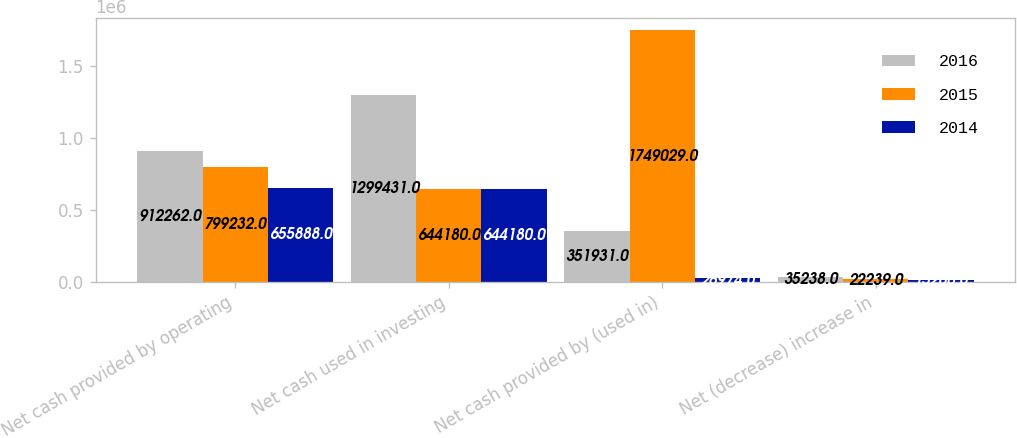Convert chart. <chart><loc_0><loc_0><loc_500><loc_500><stacked_bar_chart><ecel><fcel>Net cash provided by operating<fcel>Net cash used in investing<fcel>Net cash provided by (used in)<fcel>Net (decrease) increase in<nl><fcel>2016<fcel>912262<fcel>1.29943e+06<fcel>351931<fcel>35238<nl><fcel>2015<fcel>799232<fcel>644180<fcel>1.74903e+06<fcel>22239<nl><fcel>2014<fcel>655888<fcel>644180<fcel>26974<fcel>15266<nl></chart> 